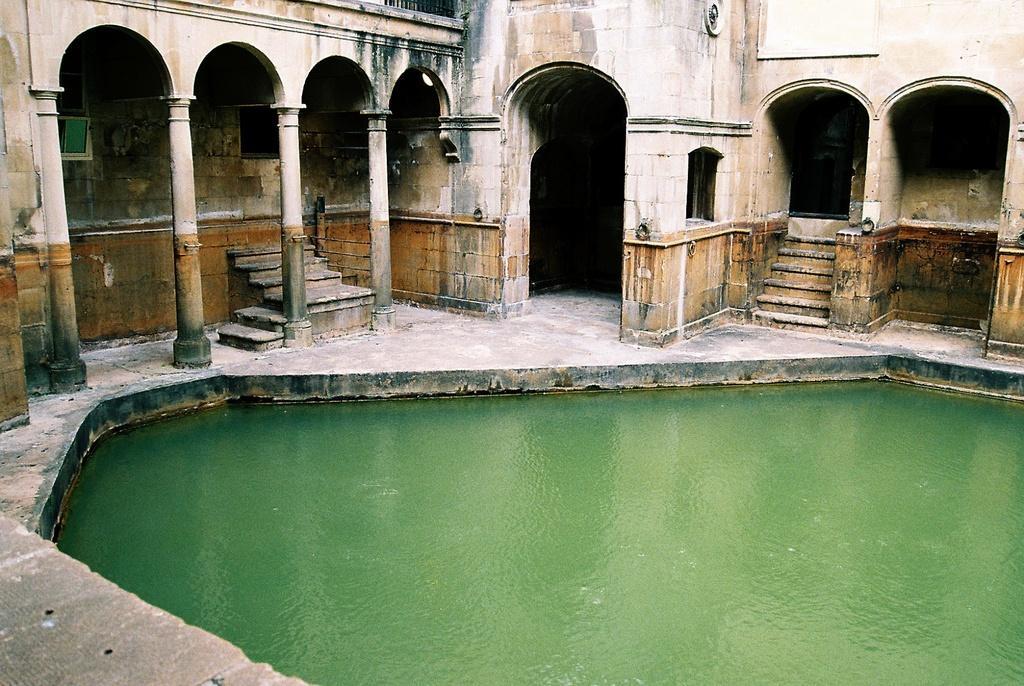Describe this image in one or two sentences. In picture we can observe a pond. There are some pillars and stairs. We can observe walls and an entrance here. 